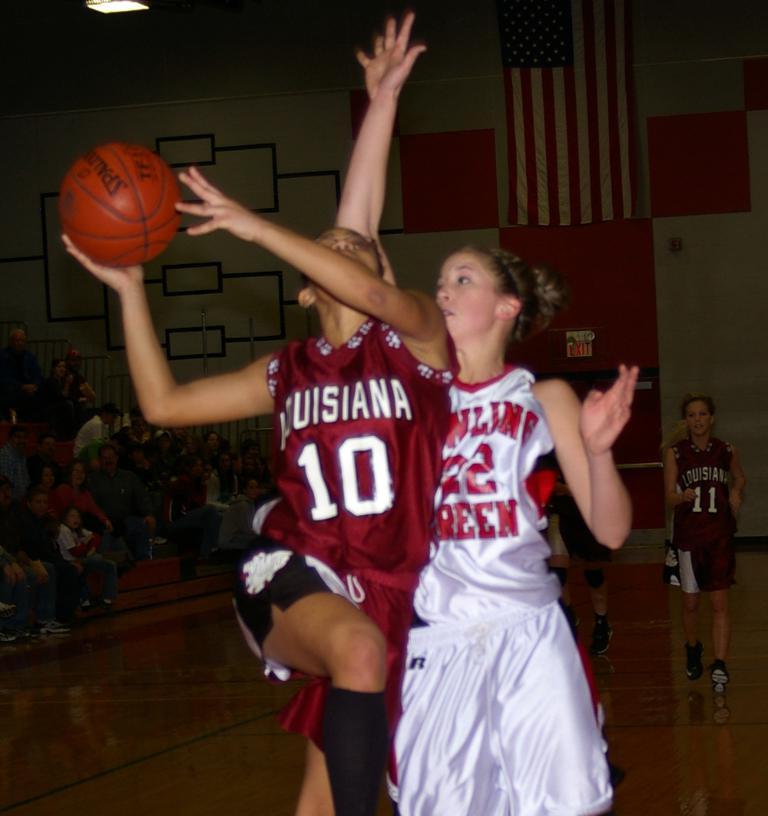What number shirt is the player on the left wearing?
Provide a short and direct response. 10. What number is the player in white?
Make the answer very short. 22. 